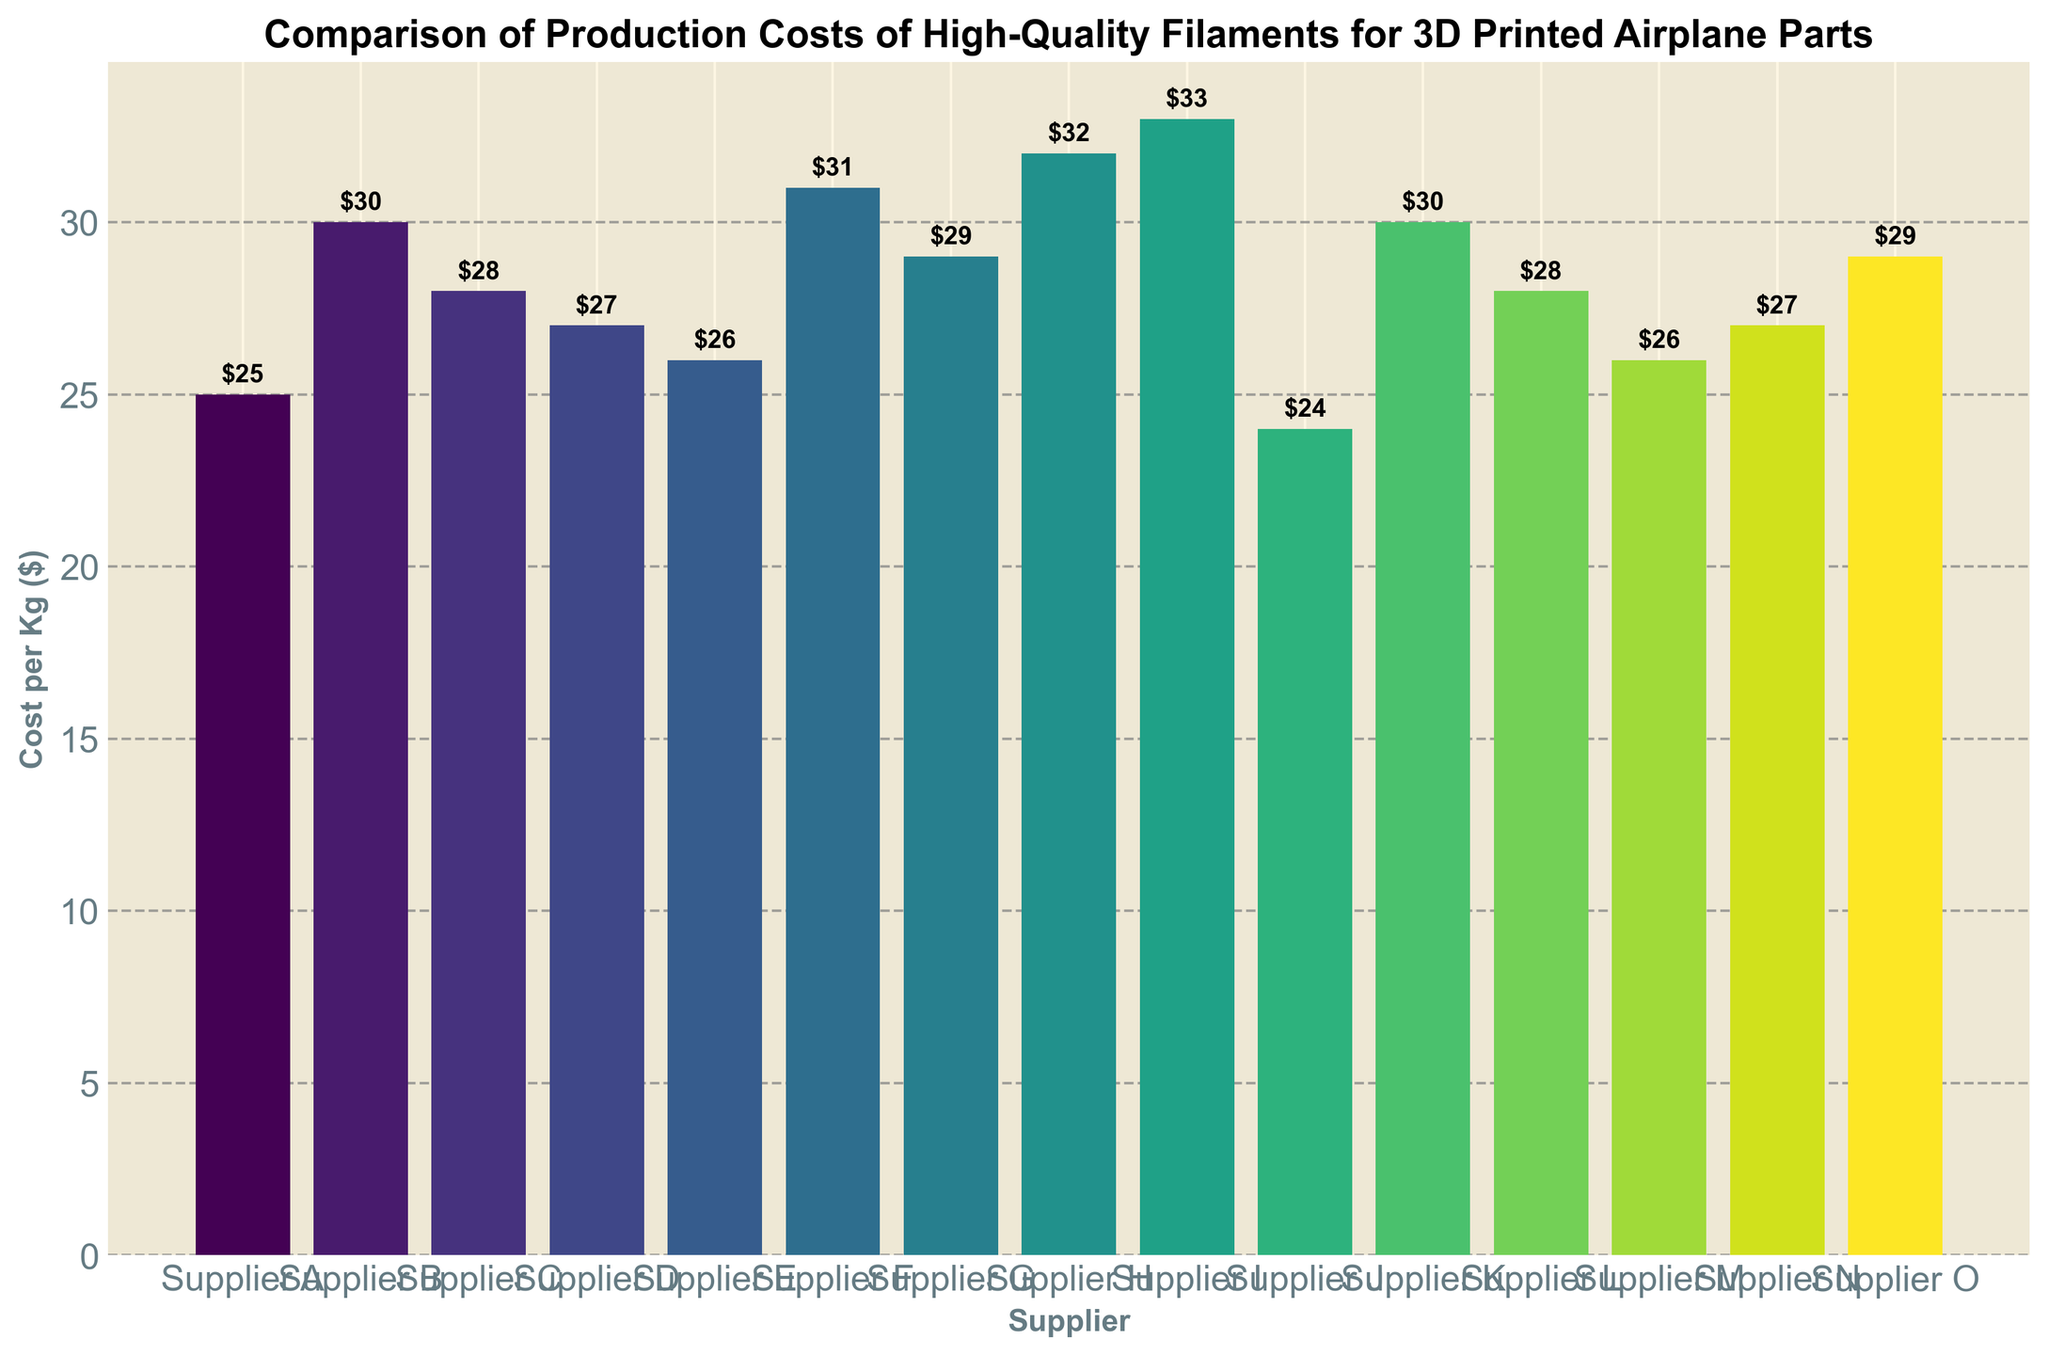What is the cost per kilogram of filament from the most expensive supplier? The highest bar represents the most expensive supplier, which has a cost of $33 per kilogram.
Answer: $33 Which supplier offers the cheapest filament per kilogram? The shortest bar on the chart indicates the supplier with the lowest cost, which is Supplier J with a cost of $24 per kilogram.
Answer: Supplier J What is the average cost per kilogram of filament across all suppliers? To find the average, sum all the costs and divide by the number of suppliers: (25 + 30 + 28 + 27 + 26 + 31 + 29 + 32 + 33 + 24 + 30 + 28 + 26 + 27 + 29) / 15 = 425 / 15
Answer: $28.33 Which suppliers have a cost per kilogram greater than $30? From the chart, the suppliers with bars higher than the $30 mark are Supplier B, Supplier F, Supplier H, Supplier I, and Supplier K.
Answer: Supplier B, Supplier F, Supplier H, Supplier I, Supplier K How much more expensive is Supplier I compared to Supplier A? The cost per kilogram for Supplier I is $33, and for Supplier A, it is $25. The difference is 33 - 25 = $8.
Answer: $8 What is the difference in cost between the most expensive and the cheapest suppliers? The most expensive supplier (Supplier I) has a cost of $33, and the cheapest supplier (Supplier J) has a cost of $24. The difference is 33 - 24 = $9.
Answer: $9 What is the combined cost per kilogram of filament from Supplier D and Supplier E? The cost per kilogram for Supplier D is $27 and for Supplier E is $26. The combined cost is 27 + 26 = $53.
Answer: $53 Are there any suppliers with the same cost per kilogram? The chart shows that Supplier B and Supplier K both have a cost of $30 per kilogram.
Answer: Supplier B, Supplier K Which supplier’s bar is the fourth tallest in the chart? By evaluating the heights of the bars, the fourth tallest bar belongs to Supplier G with a cost of $29 per kilogram.
Answer: Supplier G 